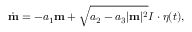Convert formula to latex. <formula><loc_0><loc_0><loc_500><loc_500>\dot { \mathbf m } = - a _ { 1 } \mathbf m + \sqrt { a _ { 2 } - a _ { 3 } | \mathbf m | ^ { 2 } } I \cdot \boldsymbol \eta ( t ) ,</formula> 